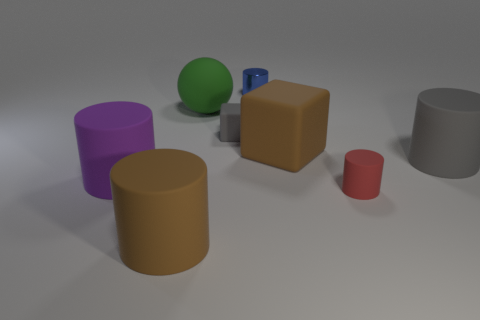Subtract all small blue cylinders. How many cylinders are left? 4 Add 1 gray objects. How many objects exist? 9 Subtract all gray cubes. How many cubes are left? 1 Subtract 1 cubes. How many cubes are left? 1 Subtract all cylinders. How many objects are left? 3 Subtract all purple cubes. How many blue cylinders are left? 1 Subtract all small red blocks. Subtract all tiny red matte objects. How many objects are left? 7 Add 2 gray cylinders. How many gray cylinders are left? 3 Add 6 small purple shiny blocks. How many small purple shiny blocks exist? 6 Subtract 0 green blocks. How many objects are left? 8 